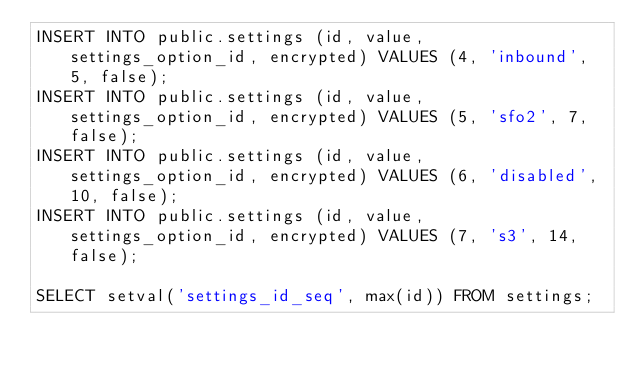Convert code to text. <code><loc_0><loc_0><loc_500><loc_500><_SQL_>INSERT INTO public.settings (id, value, settings_option_id, encrypted) VALUES (4, 'inbound', 5, false);
INSERT INTO public.settings (id, value, settings_option_id, encrypted) VALUES (5, 'sfo2', 7, false);
INSERT INTO public.settings (id, value, settings_option_id, encrypted) VALUES (6, 'disabled', 10, false);
INSERT INTO public.settings (id, value, settings_option_id, encrypted) VALUES (7, 's3', 14, false);

SELECT setval('settings_id_seq', max(id)) FROM settings;</code> 